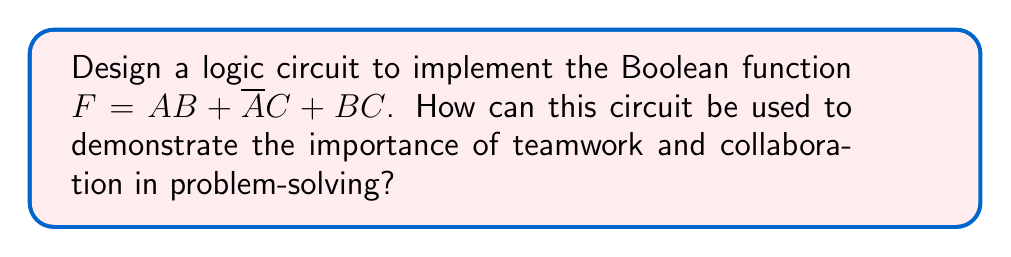Can you solve this math problem? Let's approach this step-by-step:

1) First, we need to understand the given Boolean function:
   $F = AB + \overline{A}C + BC$

2) This function has three terms, each requiring its own AND gate:
   - $AB$
   - $\overline{A}C$
   - $BC$

3) We'll need an OR gate to combine these terms.

4) For the $\overline{A}C$ term, we'll need a NOT gate for $A$.

5) The circuit design will be as follows:
   - Input $A$ and $B$ to an AND gate
   - Input $\overline{A}$ (output of NOT gate for $A$) and $C$ to another AND gate
   - Input $B$ and $C$ to a third AND gate
   - Connect the outputs of these three AND gates to a three-input OR gate

6) The output of the OR gate will be our function $F$.

[asy]
import geometry;

pair A = (0,0), B = (0,-1), C = (0,-2);
pair NOT = (1,0);
pair AND1 = (2,0), AND2 = (2,-1), AND3 = (2,-2);
pair OR = (4,-1);
pair F = (5,-1);

draw(A--NOT);
draw(NOT--(1,-1)--(2,-1));
draw(A--(1,0.1)--(2,0.1));
draw(B--(1,-0.9)--(2,-0.9));
draw(B--(1,-1.9)--(2,-1.9));
draw(C--(1,-1.1)--(2,-1.1));
draw(C--(1,-2.1)--(2,-2.1));

draw(AND1--(3,0)--(3,-1)--(4,-1));
draw(AND2--(3,-1));
draw(AND3--(3,-2)--(3,-1));

draw(OR--F);

label("A", A, W);
label("B", B, W);
label("C", C, W);
label("NOT", NOT, E);
label("AND", AND1, E);
label("AND", AND2, E);
label("AND", AND3, E);
label("OR", OR, E);
label("F", F, E);
[/asy]

7) This circuit demonstrates teamwork and collaboration as each gate (team member) has a specific role:
   - The NOT gate prepares input for others
   - The AND gates work on different parts of the problem
   - The OR gate combines all efforts for the final solution

8) Just as in teamwork, the final output (solution) depends on all parts working together effectively.
Answer: Circuit with 1 NOT gate, 3 AND gates, 1 OR gate; teamwork analogy: gates as team members with specific roles collaborating for final output. 